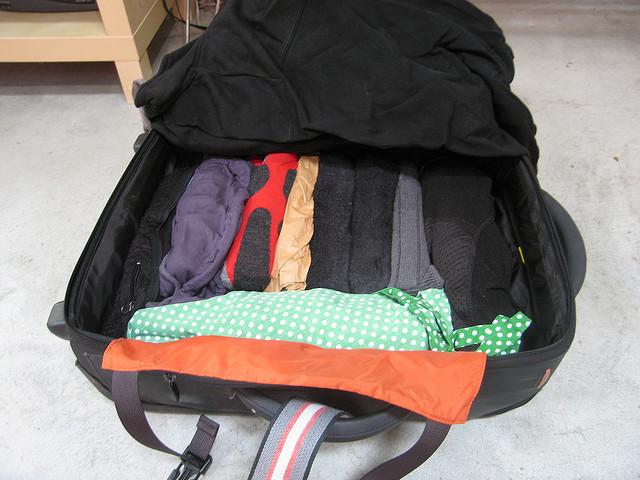What is in the bag?
Short answer required. Clothes. Is the floor carpeted?
Quick response, please. Yes. Is this person ready for a trip?
Concise answer only. Yes. 